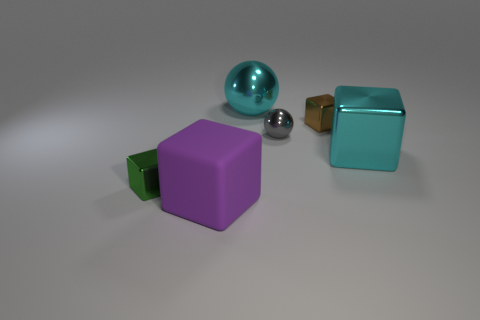Is the large metallic ball the same color as the big metallic cube?
Offer a very short reply. Yes. How big is the gray shiny sphere?
Offer a terse response. Small. How many matte things are big blocks or cyan spheres?
Offer a terse response. 1. There is a small shiny cube to the right of the large thing that is in front of the green metal thing; how many tiny gray spheres are in front of it?
Your response must be concise. 1. There is a brown thing that is made of the same material as the green block; what size is it?
Provide a succinct answer. Small. How many large metal things have the same color as the big shiny cube?
Offer a terse response. 1. There is a block that is in front of the green shiny object; is it the same size as the large cyan sphere?
Your answer should be very brief. Yes. The metallic object that is on the left side of the brown shiny cube and to the right of the big shiny sphere is what color?
Your answer should be very brief. Gray. How many objects are either small green objects or large metallic objects behind the matte cube?
Offer a terse response. 3. There is a large cube that is to the left of the small block to the right of the tiny metallic block in front of the cyan shiny cube; what is its material?
Offer a very short reply. Rubber. 